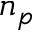Convert formula to latex. <formula><loc_0><loc_0><loc_500><loc_500>n _ { p }</formula> 